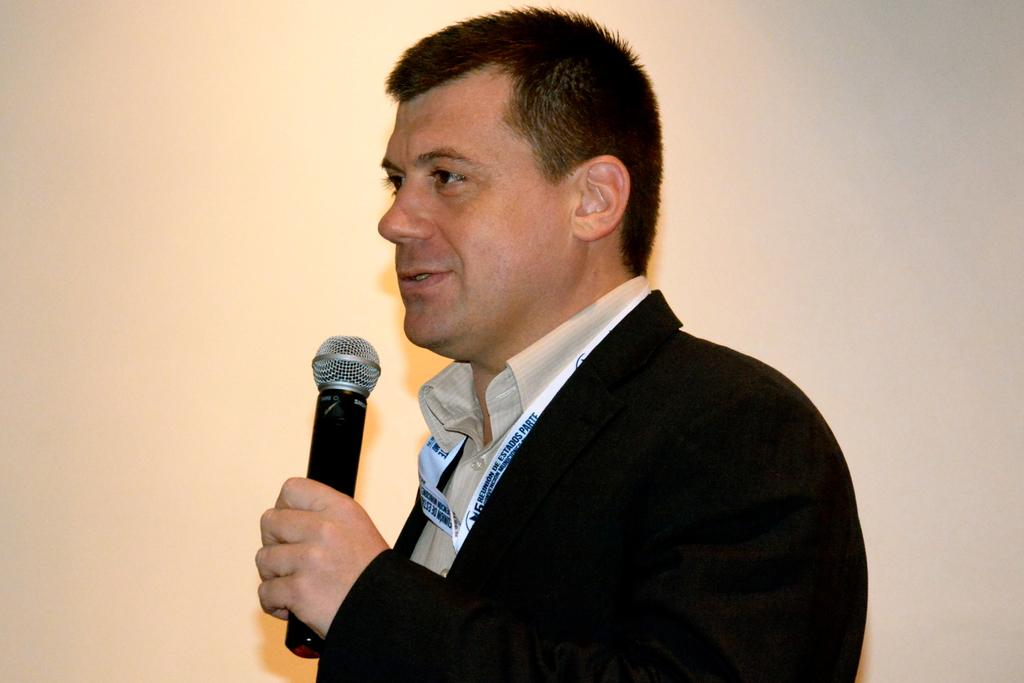Who is present in the image? There is a person in the image. What is the person wearing? The person is wearing a black suit. What is the person holding in the image? The person is holding a microphone. What can be seen in the background of the image? There is a wall in the background of the image. What color is the sand in the image? There is no sand present in the image. Who is the person's partner in the image? The image does not show any other person, so it is not possible to determine if the person has a partner in the image. 